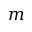<formula> <loc_0><loc_0><loc_500><loc_500>m</formula> 